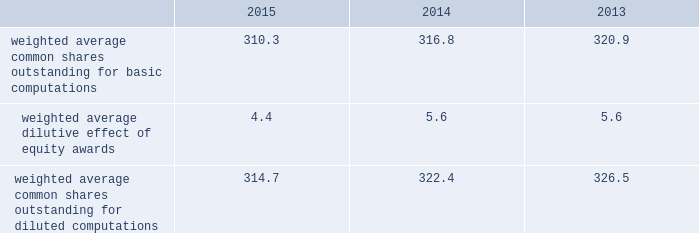2015 and 2014 was $ 1.5 billion and $ 1.3 billion .
The aggregate notional amount of our outstanding foreign currency hedges at december 31 , 2015 and 2014 was $ 4.1 billion and $ 804 million .
Derivative instruments did not have a material impact on net earnings and comprehensive income during 2015 , 2014 and 2013 .
Substantially all of our derivatives are designated for hedge accounting .
See note 16 for more information on the fair value measurements related to our derivative instruments .
Recent accounting pronouncements 2013 in may 2014 , the fasb issued a new standard that will change the way we recognize revenue and significantly expand the disclosure requirements for revenue arrangements .
On july 9 , 2015 , the fasb approved a one-year deferral of the effective date of the standard to 2018 for public companies , with an option that would permit companies to adopt the standard in 2017 .
Early adoption prior to 2017 is not permitted .
The new standard may be adopted either retrospectively or on a modified retrospective basis whereby the new standard would be applied to new contracts and existing contracts with remaining performance obligations as of the effective date , with a cumulative catch-up adjustment recorded to beginning retained earnings at the effective date for existing contracts with remaining performance obligations .
In addition , the fasb is contemplating making additional changes to certain elements of the new standard .
We are currently evaluating the methods of adoption allowed by the new standard and the effect the standard is expected to have on our consolidated financial statements and related disclosures .
As the new standard will supersede substantially all existing revenue guidance affecting us under gaap , it could impact revenue and cost recognition on thousands of contracts across all our business segments , in addition to our business processes and our information technology systems .
As a result , our evaluation of the effect of the new standard will extend over future periods .
In september 2015 , the fasb issued a new standard that simplifies the accounting for adjustments made to preliminary amounts recognized in a business combination by eliminating the requirement to retrospectively account for those adjustments .
Instead , adjustments will be recognized in the period in which the adjustments are determined , including the effect on earnings of any amounts that would have been recorded in previous periods if the accounting had been completed at the acquisition date .
We adopted the standard on january 1 , 2016 and will prospectively apply the standard to business combination adjustments identified after the date of adoption .
In november 2015 , the fasb issued a new standard that simplifies the presentation of deferred income taxes and requires that deferred tax assets and liabilities , as well as any related valuation allowance , be classified as noncurrent in our consolidated balance sheets .
The standard is effective january 1 , 2017 , with early adoption permitted .
The standard may be applied either prospectively from the date of adoption or retrospectively to all prior periods presented .
We are currently evaluating when we will adopt the standard and the method of adoption .
Note 2 2013 earnings per share the weighted average number of shares outstanding used to compute earnings per common share were as follows ( in millions ) : .
We compute basic and diluted earnings per common share by dividing net earnings by the respective weighted average number of common shares outstanding for the periods presented .
Our calculation of diluted earnings per common share also includes the dilutive effects for the assumed vesting of outstanding restricted stock units and exercise of outstanding stock options based on the treasury stock method .
The computation of diluted earnings per common share excluded 2.4 million stock options for the year ended december 31 , 2013 because their inclusion would have been anti-dilutive , primarily due to their exercise prices exceeding the average market prices of our common stock during the respective periods .
There were no anti-dilutive equity awards for the years ended december 31 , 2015 and 2014. .
What was the change in weighted average common shares outstanding for diluted computations from 2014 to 2015 , in millions? 
Computations: (314.7 - 322.4)
Answer: -7.7. 